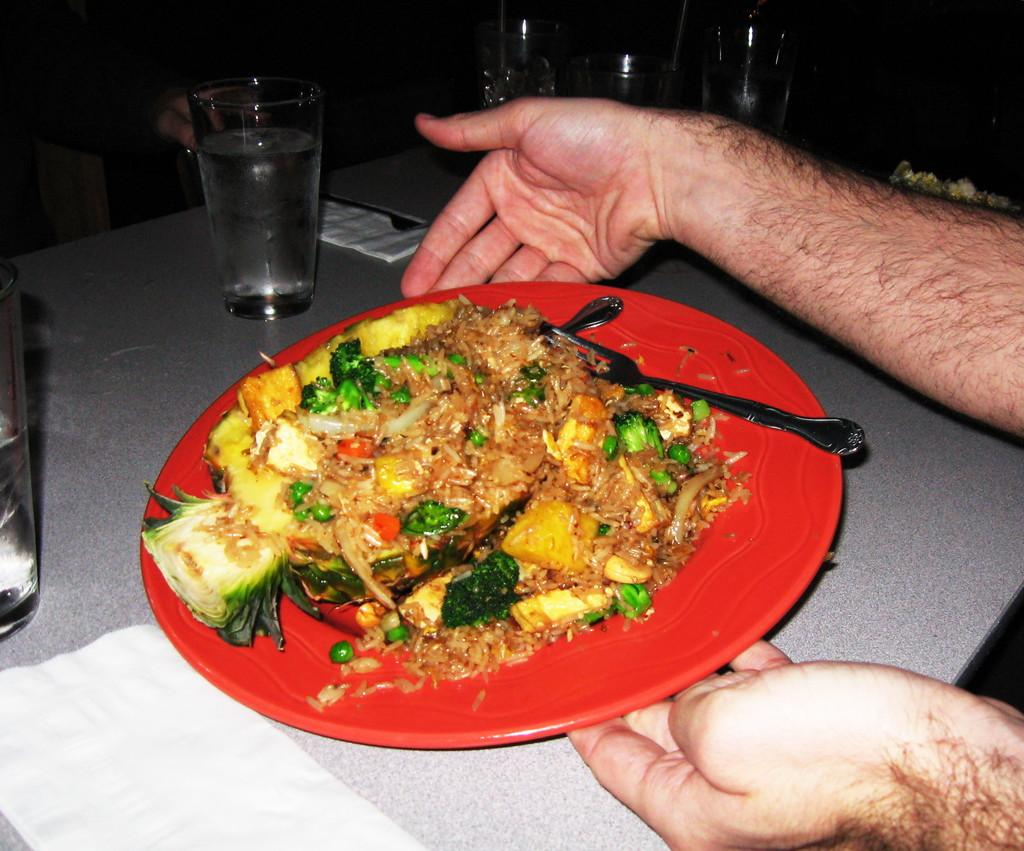What is on the plate that is visible in the image? There is food in the plate in the image. What utensils are visible in the image? There is a fork and a spoon in the image. Who is holding the plate in the image? A human is holding a plate with their hands in the image. What piece of furniture is present in the image? There is a table in the image. What items are on the table in the image? There are glasses, a jug, and napkins on the table in the image. Where is the hammer located in the image? There is no hammer present in the image. What books are being read by the person in the image? There are no books or reading activity depicted in the image. 